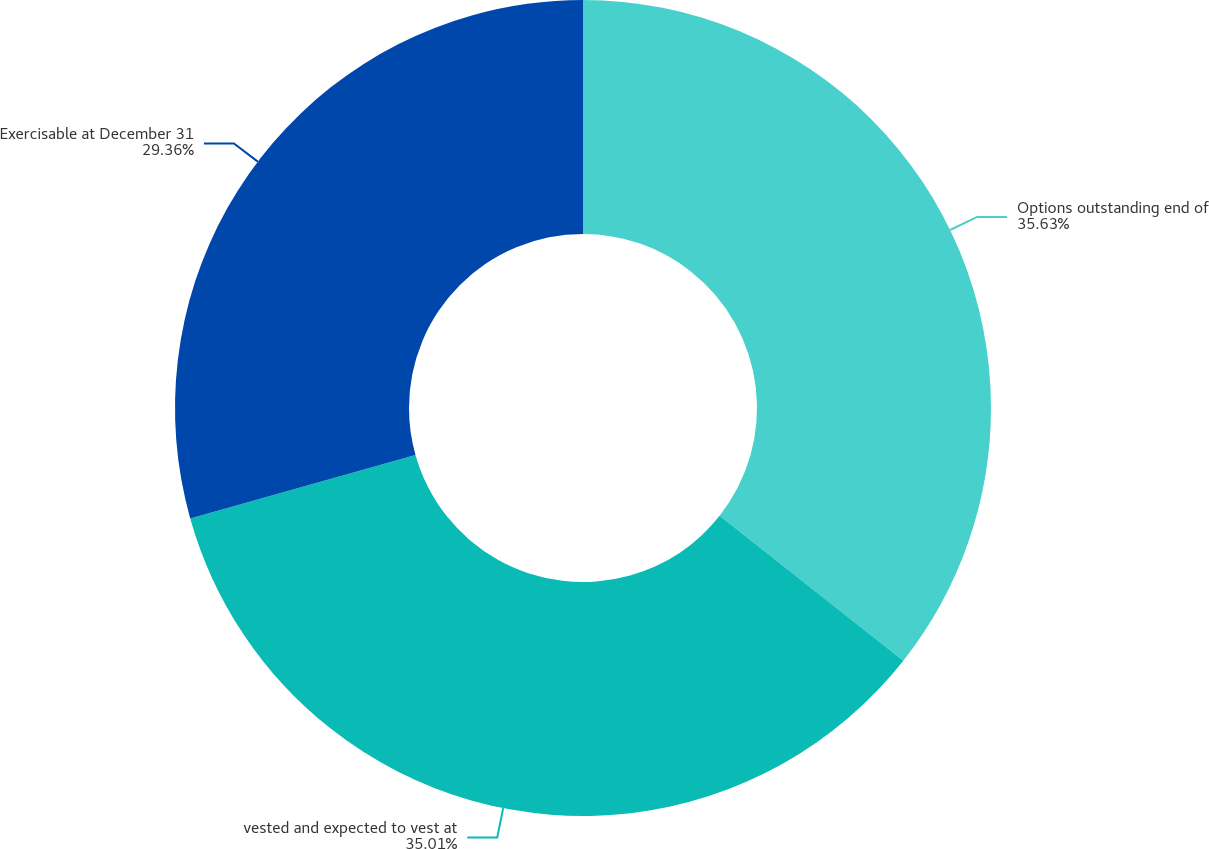Convert chart to OTSL. <chart><loc_0><loc_0><loc_500><loc_500><pie_chart><fcel>Options outstanding end of<fcel>vested and expected to vest at<fcel>Exercisable at December 31<nl><fcel>35.63%<fcel>35.01%<fcel>29.36%<nl></chart> 